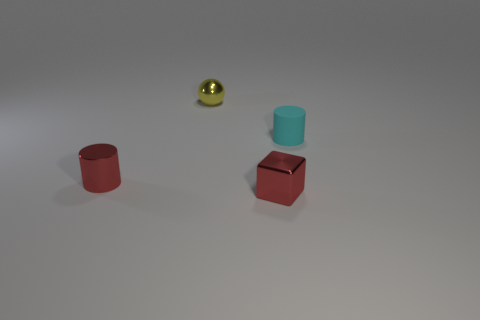There is a red thing that is the same shape as the cyan matte thing; what size is it?
Your answer should be compact. Small. What is the size of the cylinder that is the same color as the small block?
Give a very brief answer. Small. What is the material of the cyan thing?
Ensure brevity in your answer.  Rubber. Do the small cylinder that is in front of the cyan rubber object and the tiny cyan thing have the same material?
Your response must be concise. No. Is the number of tiny yellow objects that are in front of the tiny yellow object less than the number of red blocks?
Make the answer very short. Yes. What is the color of the ball that is the same size as the cyan object?
Offer a very short reply. Yellow. How many tiny yellow objects are the same shape as the tiny cyan object?
Your answer should be compact. 0. The cylinder right of the yellow metal sphere is what color?
Offer a very short reply. Cyan. What number of rubber things are either small cyan cylinders or small cyan blocks?
Ensure brevity in your answer.  1. What is the shape of the object that is the same color as the small block?
Give a very brief answer. Cylinder. 